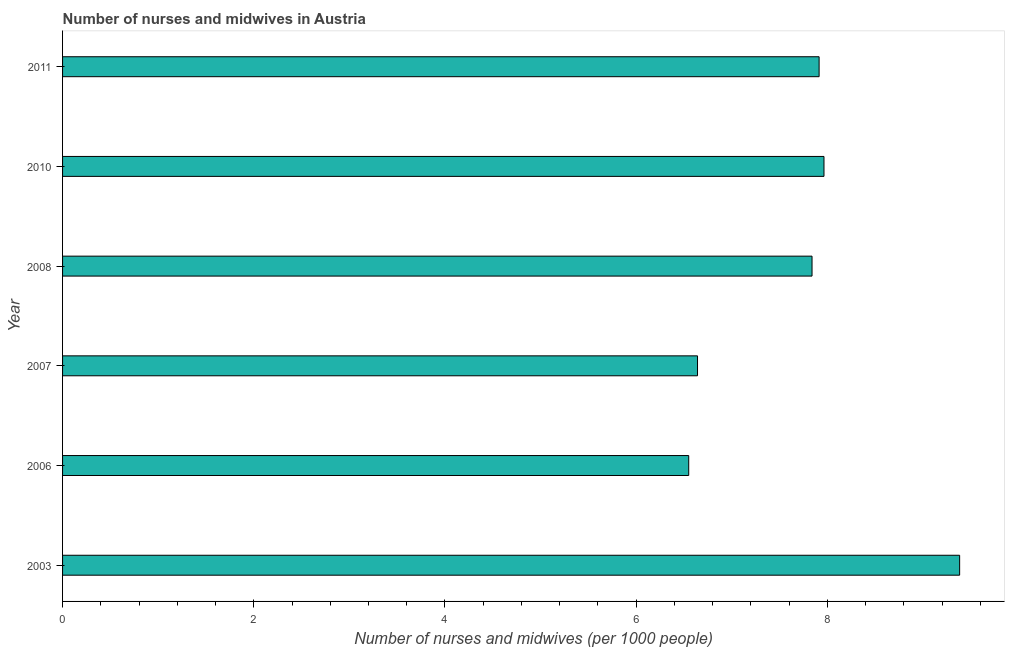Does the graph contain grids?
Offer a terse response. No. What is the title of the graph?
Your answer should be very brief. Number of nurses and midwives in Austria. What is the label or title of the X-axis?
Offer a terse response. Number of nurses and midwives (per 1000 people). What is the label or title of the Y-axis?
Provide a succinct answer. Year. What is the number of nurses and midwives in 2011?
Offer a terse response. 7.91. Across all years, what is the maximum number of nurses and midwives?
Offer a terse response. 9.38. Across all years, what is the minimum number of nurses and midwives?
Keep it short and to the point. 6.55. In which year was the number of nurses and midwives maximum?
Make the answer very short. 2003. In which year was the number of nurses and midwives minimum?
Ensure brevity in your answer.  2006. What is the sum of the number of nurses and midwives?
Your answer should be compact. 46.3. What is the difference between the number of nurses and midwives in 2006 and 2007?
Provide a succinct answer. -0.09. What is the average number of nurses and midwives per year?
Provide a short and direct response. 7.72. What is the median number of nurses and midwives?
Keep it short and to the point. 7.88. What is the ratio of the number of nurses and midwives in 2003 to that in 2007?
Provide a succinct answer. 1.41. Is the number of nurses and midwives in 2007 less than that in 2010?
Your answer should be very brief. Yes. Is the difference between the number of nurses and midwives in 2003 and 2006 greater than the difference between any two years?
Ensure brevity in your answer.  Yes. What is the difference between the highest and the second highest number of nurses and midwives?
Provide a short and direct response. 1.42. Is the sum of the number of nurses and midwives in 2003 and 2011 greater than the maximum number of nurses and midwives across all years?
Provide a succinct answer. Yes. What is the difference between the highest and the lowest number of nurses and midwives?
Make the answer very short. 2.83. How many bars are there?
Offer a very short reply. 6. How many years are there in the graph?
Keep it short and to the point. 6. What is the difference between two consecutive major ticks on the X-axis?
Your response must be concise. 2. Are the values on the major ticks of X-axis written in scientific E-notation?
Your answer should be compact. No. What is the Number of nurses and midwives (per 1000 people) of 2003?
Provide a short and direct response. 9.38. What is the Number of nurses and midwives (per 1000 people) in 2006?
Offer a terse response. 6.55. What is the Number of nurses and midwives (per 1000 people) of 2007?
Keep it short and to the point. 6.64. What is the Number of nurses and midwives (per 1000 people) in 2008?
Give a very brief answer. 7.84. What is the Number of nurses and midwives (per 1000 people) in 2010?
Your answer should be compact. 7.96. What is the Number of nurses and midwives (per 1000 people) in 2011?
Your response must be concise. 7.91. What is the difference between the Number of nurses and midwives (per 1000 people) in 2003 and 2006?
Make the answer very short. 2.83. What is the difference between the Number of nurses and midwives (per 1000 people) in 2003 and 2007?
Give a very brief answer. 2.74. What is the difference between the Number of nurses and midwives (per 1000 people) in 2003 and 2008?
Offer a very short reply. 1.54. What is the difference between the Number of nurses and midwives (per 1000 people) in 2003 and 2010?
Provide a succinct answer. 1.42. What is the difference between the Number of nurses and midwives (per 1000 people) in 2003 and 2011?
Make the answer very short. 1.47. What is the difference between the Number of nurses and midwives (per 1000 people) in 2006 and 2007?
Make the answer very short. -0.09. What is the difference between the Number of nurses and midwives (per 1000 people) in 2006 and 2008?
Your answer should be compact. -1.29. What is the difference between the Number of nurses and midwives (per 1000 people) in 2006 and 2010?
Your response must be concise. -1.42. What is the difference between the Number of nurses and midwives (per 1000 people) in 2006 and 2011?
Keep it short and to the point. -1.36. What is the difference between the Number of nurses and midwives (per 1000 people) in 2007 and 2008?
Your answer should be compact. -1.2. What is the difference between the Number of nurses and midwives (per 1000 people) in 2007 and 2010?
Provide a short and direct response. -1.32. What is the difference between the Number of nurses and midwives (per 1000 people) in 2007 and 2011?
Your answer should be very brief. -1.27. What is the difference between the Number of nurses and midwives (per 1000 people) in 2008 and 2010?
Your answer should be compact. -0.12. What is the difference between the Number of nurses and midwives (per 1000 people) in 2008 and 2011?
Offer a terse response. -0.07. What is the difference between the Number of nurses and midwives (per 1000 people) in 2010 and 2011?
Make the answer very short. 0.05. What is the ratio of the Number of nurses and midwives (per 1000 people) in 2003 to that in 2006?
Offer a terse response. 1.43. What is the ratio of the Number of nurses and midwives (per 1000 people) in 2003 to that in 2007?
Offer a terse response. 1.41. What is the ratio of the Number of nurses and midwives (per 1000 people) in 2003 to that in 2008?
Give a very brief answer. 1.2. What is the ratio of the Number of nurses and midwives (per 1000 people) in 2003 to that in 2010?
Ensure brevity in your answer.  1.18. What is the ratio of the Number of nurses and midwives (per 1000 people) in 2003 to that in 2011?
Keep it short and to the point. 1.19. What is the ratio of the Number of nurses and midwives (per 1000 people) in 2006 to that in 2008?
Give a very brief answer. 0.83. What is the ratio of the Number of nurses and midwives (per 1000 people) in 2006 to that in 2010?
Provide a short and direct response. 0.82. What is the ratio of the Number of nurses and midwives (per 1000 people) in 2006 to that in 2011?
Your answer should be very brief. 0.83. What is the ratio of the Number of nurses and midwives (per 1000 people) in 2007 to that in 2008?
Make the answer very short. 0.85. What is the ratio of the Number of nurses and midwives (per 1000 people) in 2007 to that in 2010?
Offer a very short reply. 0.83. What is the ratio of the Number of nurses and midwives (per 1000 people) in 2007 to that in 2011?
Your answer should be compact. 0.84. 